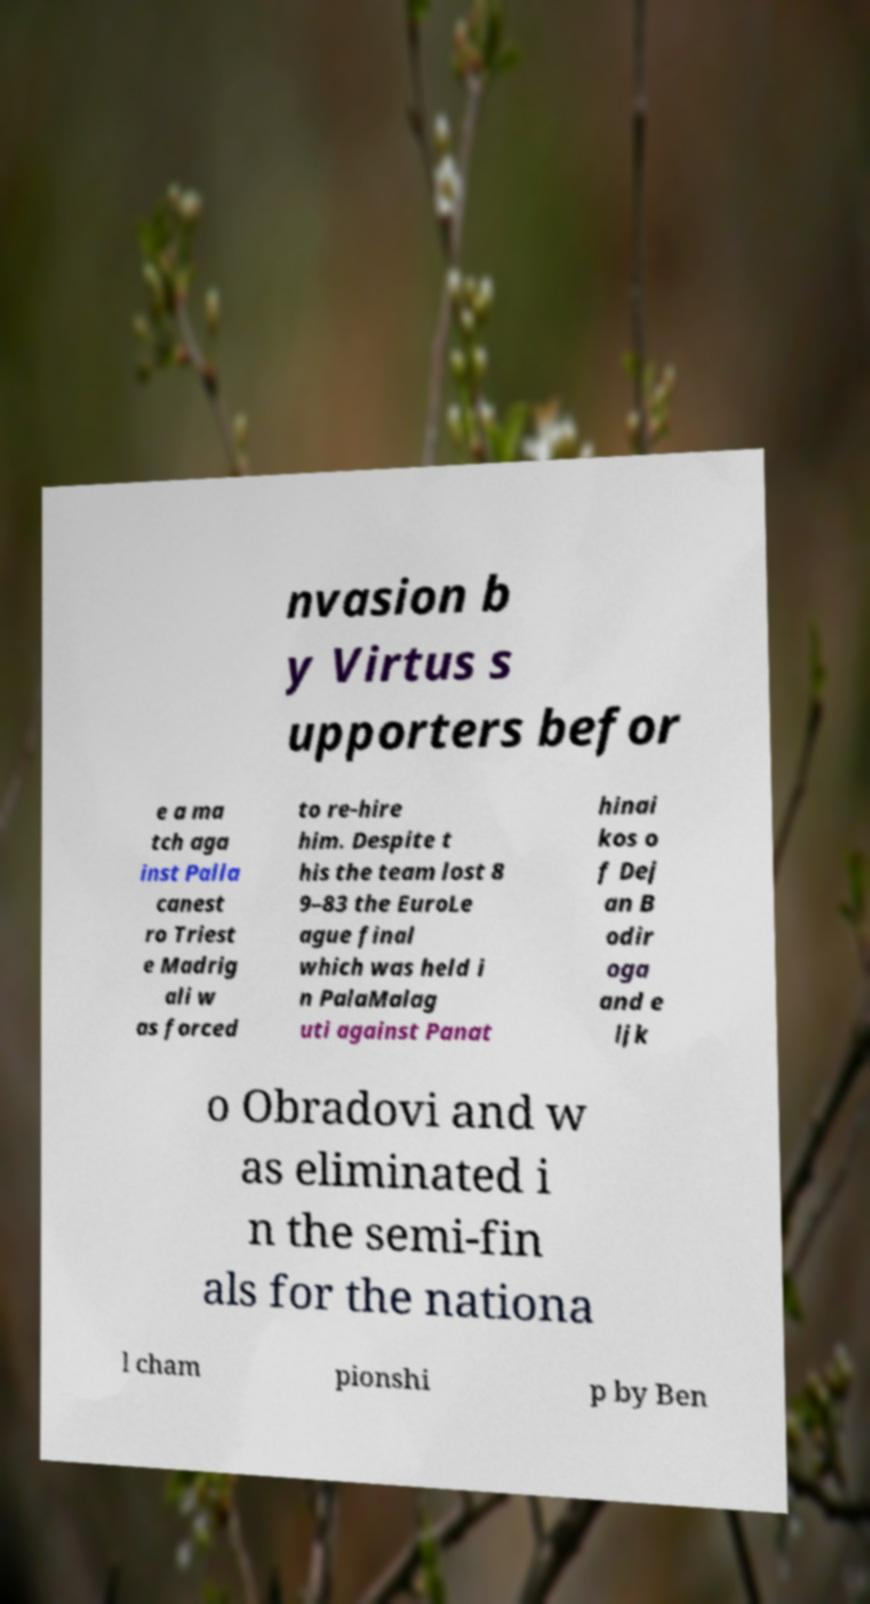Could you extract and type out the text from this image? nvasion b y Virtus s upporters befor e a ma tch aga inst Palla canest ro Triest e Madrig ali w as forced to re-hire him. Despite t his the team lost 8 9–83 the EuroLe ague final which was held i n PalaMalag uti against Panat hinai kos o f Dej an B odir oga and e ljk o Obradovi and w as eliminated i n the semi-fin als for the nationa l cham pionshi p by Ben 